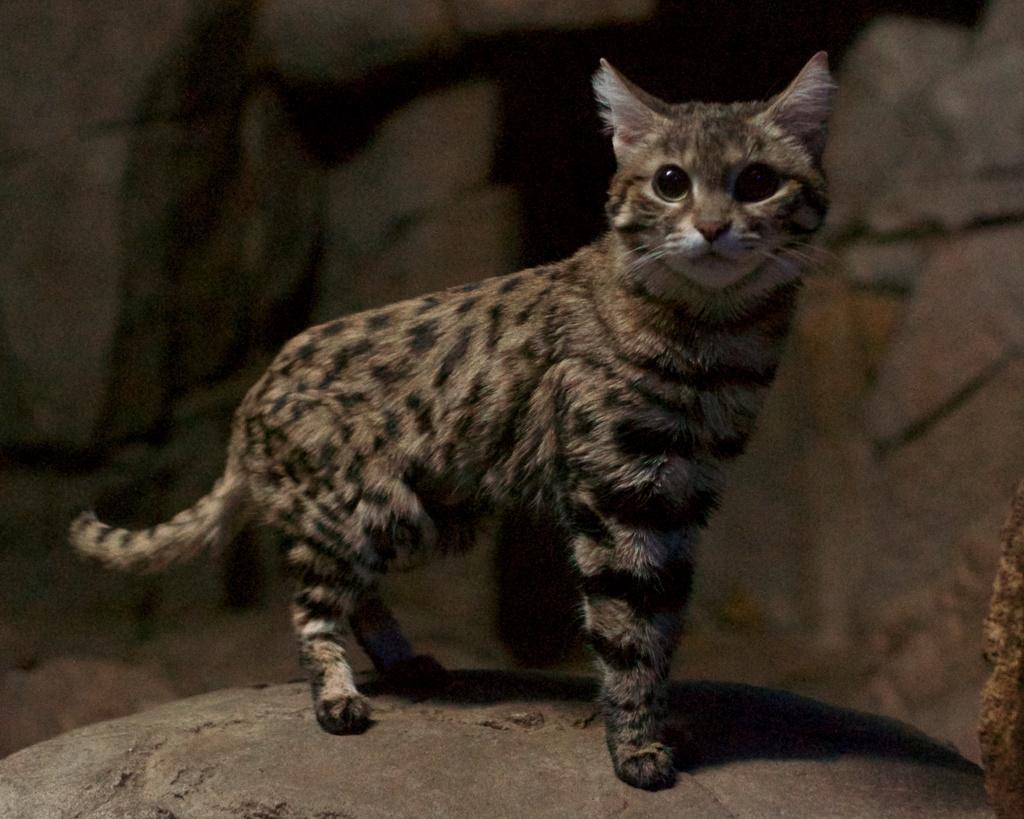What animal can be seen in the image? There is a cat in the image. What colors are present on the cat? The cat has black and brown colors. What is the cat standing on? The cat is standing on a rock. What type of landscape is visible in the background? There are rock mountains in the background of the image. What does the cat taste like in the image? The image does not provide any information about the taste of the cat, as it is a visual representation and not an edible object. 